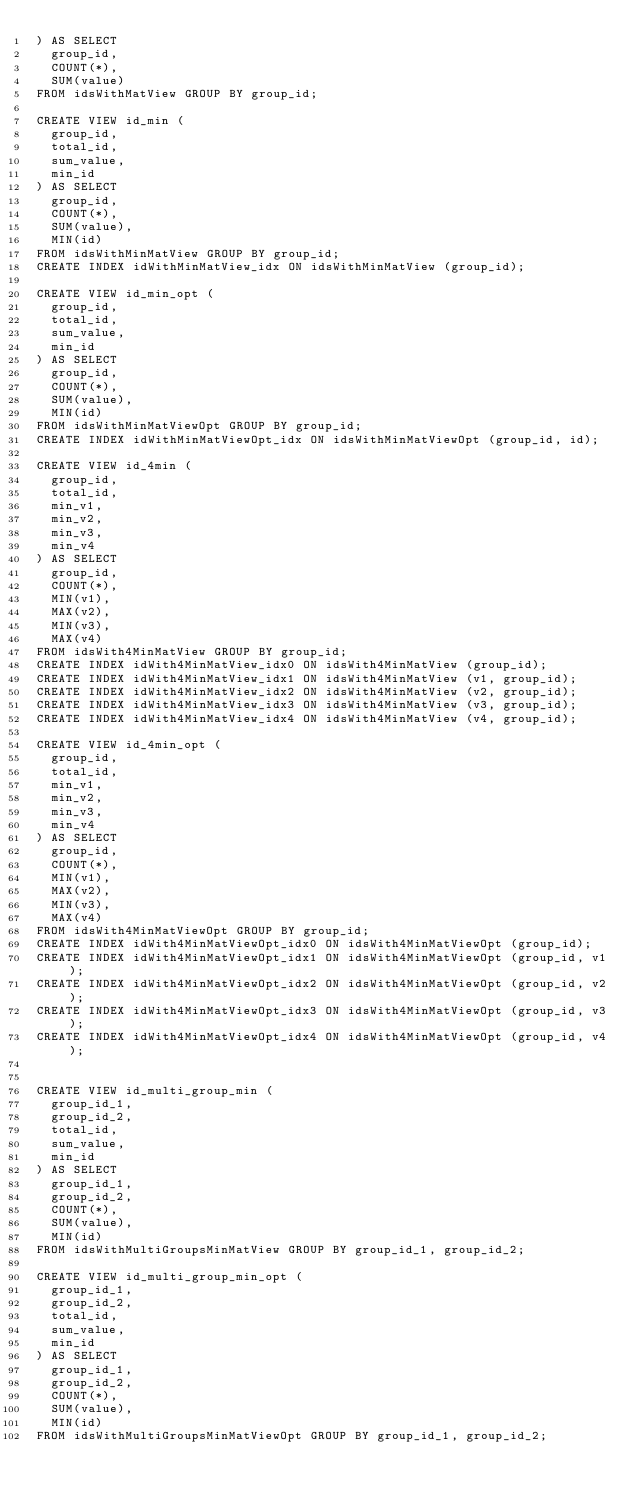<code> <loc_0><loc_0><loc_500><loc_500><_SQL_>) AS SELECT 
  group_id,
  COUNT(*),
  SUM(value) 
FROM idsWithMatView GROUP BY group_id;

CREATE VIEW id_min (
  group_id,
  total_id,
  sum_value,
  min_id
) AS SELECT 
  group_id,
  COUNT(*),
  SUM(value),
  MIN(id) 
FROM idsWithMinMatView GROUP BY group_id;
CREATE INDEX idWithMinMatView_idx ON idsWithMinMatView (group_id);

CREATE VIEW id_min_opt (
  group_id,
  total_id,
  sum_value,
  min_id
) AS SELECT 
  group_id,
  COUNT(*),
  SUM(value),
  MIN(id) 
FROM idsWithMinMatViewOpt GROUP BY group_id;
CREATE INDEX idWithMinMatViewOpt_idx ON idsWithMinMatViewOpt (group_id, id);

CREATE VIEW id_4min (
  group_id,
  total_id,
  min_v1,
  min_v2,
  min_v3,
  min_v4
) AS SELECT 
  group_id,
  COUNT(*),
  MIN(v1),
  MAX(v2),
  MIN(v3),
  MAX(v4)
FROM idsWith4MinMatView GROUP BY group_id;
CREATE INDEX idWith4MinMatView_idx0 ON idsWith4MinMatView (group_id);
CREATE INDEX idWith4MinMatView_idx1 ON idsWith4MinMatView (v1, group_id);
CREATE INDEX idWith4MinMatView_idx2 ON idsWith4MinMatView (v2, group_id);
CREATE INDEX idWith4MinMatView_idx3 ON idsWith4MinMatView (v3, group_id);
CREATE INDEX idWith4MinMatView_idx4 ON idsWith4MinMatView (v4, group_id);

CREATE VIEW id_4min_opt (
  group_id,
  total_id,
  min_v1,
  min_v2,
  min_v3,
  min_v4
) AS SELECT 
  group_id,
  COUNT(*),
  MIN(v1),
  MAX(v2),
  MIN(v3),
  MAX(v4)
FROM idsWith4MinMatViewOpt GROUP BY group_id;
CREATE INDEX idWith4MinMatViewOpt_idx0 ON idsWith4MinMatViewOpt (group_id);
CREATE INDEX idWith4MinMatViewOpt_idx1 ON idsWith4MinMatViewOpt (group_id, v1);
CREATE INDEX idWith4MinMatViewOpt_idx2 ON idsWith4MinMatViewOpt (group_id, v2);
CREATE INDEX idWith4MinMatViewOpt_idx3 ON idsWith4MinMatViewOpt (group_id, v3);
CREATE INDEX idWith4MinMatViewOpt_idx4 ON idsWith4MinMatViewOpt (group_id, v4);


CREATE VIEW id_multi_group_min (
  group_id_1,
  group_id_2,
  total_id,
  sum_value,
  min_id
) AS SELECT
  group_id_1,
  group_id_2,
  COUNT(*),
  SUM(value),
  MIN(id)
FROM idsWithMultiGroupsMinMatView GROUP BY group_id_1, group_id_2;

CREATE VIEW id_multi_group_min_opt (
  group_id_1,
  group_id_2,
  total_id,
  sum_value,
  min_id
) AS SELECT
  group_id_1,
  group_id_2,
  COUNT(*),
  SUM(value),
  MIN(id)
FROM idsWithMultiGroupsMinMatViewOpt GROUP BY group_id_1, group_id_2;</code> 